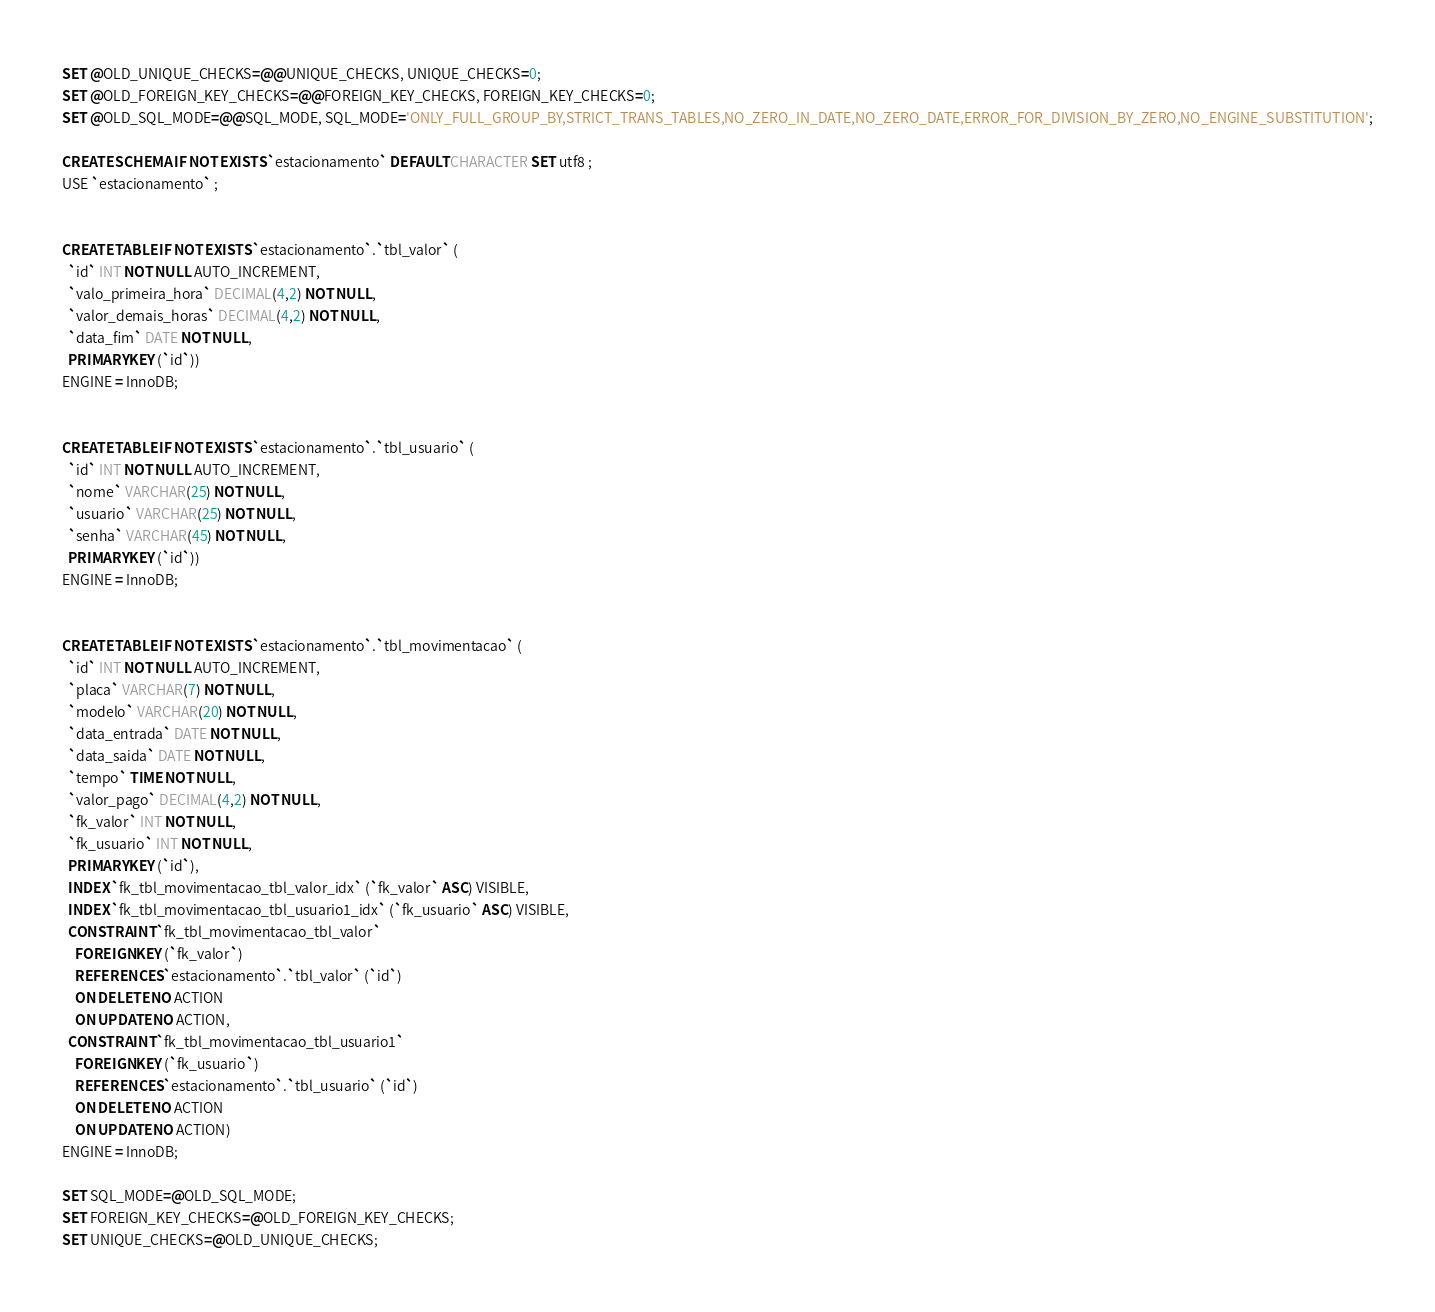<code> <loc_0><loc_0><loc_500><loc_500><_SQL_>
SET @OLD_UNIQUE_CHECKS=@@UNIQUE_CHECKS, UNIQUE_CHECKS=0;
SET @OLD_FOREIGN_KEY_CHECKS=@@FOREIGN_KEY_CHECKS, FOREIGN_KEY_CHECKS=0;
SET @OLD_SQL_MODE=@@SQL_MODE, SQL_MODE='ONLY_FULL_GROUP_BY,STRICT_TRANS_TABLES,NO_ZERO_IN_DATE,NO_ZERO_DATE,ERROR_FOR_DIVISION_BY_ZERO,NO_ENGINE_SUBSTITUTION';

CREATE SCHEMA IF NOT EXISTS `estacionamento` DEFAULT CHARACTER SET utf8 ;
USE `estacionamento` ;


CREATE TABLE IF NOT EXISTS `estacionamento`.`tbl_valor` (
  `id` INT NOT NULL AUTO_INCREMENT,
  `valo_primeira_hora` DECIMAL(4,2) NOT NULL,
  `valor_demais_horas` DECIMAL(4,2) NOT NULL,
  `data_fim` DATE NOT NULL,
  PRIMARY KEY (`id`))
ENGINE = InnoDB;


CREATE TABLE IF NOT EXISTS `estacionamento`.`tbl_usuario` (
  `id` INT NOT NULL AUTO_INCREMENT,
  `nome` VARCHAR(25) NOT NULL,
  `usuario` VARCHAR(25) NOT NULL,
  `senha` VARCHAR(45) NOT NULL,
  PRIMARY KEY (`id`))
ENGINE = InnoDB;


CREATE TABLE IF NOT EXISTS `estacionamento`.`tbl_movimentacao` (
  `id` INT NOT NULL AUTO_INCREMENT,
  `placa` VARCHAR(7) NOT NULL,
  `modelo` VARCHAR(20) NOT NULL,
  `data_entrada` DATE NOT NULL,
  `data_saida` DATE NOT NULL,
  `tempo` TIME NOT NULL,
  `valor_pago` DECIMAL(4,2) NOT NULL,
  `fk_valor` INT NOT NULL,
  `fk_usuario` INT NOT NULL,
  PRIMARY KEY (`id`),
  INDEX `fk_tbl_movimentacao_tbl_valor_idx` (`fk_valor` ASC) VISIBLE,
  INDEX `fk_tbl_movimentacao_tbl_usuario1_idx` (`fk_usuario` ASC) VISIBLE,
  CONSTRAINT `fk_tbl_movimentacao_tbl_valor`
    FOREIGN KEY (`fk_valor`)
    REFERENCES `estacionamento`.`tbl_valor` (`id`)
    ON DELETE NO ACTION
    ON UPDATE NO ACTION,
  CONSTRAINT `fk_tbl_movimentacao_tbl_usuario1`
    FOREIGN KEY (`fk_usuario`)
    REFERENCES `estacionamento`.`tbl_usuario` (`id`)
    ON DELETE NO ACTION
    ON UPDATE NO ACTION)
ENGINE = InnoDB;

SET SQL_MODE=@OLD_SQL_MODE;
SET FOREIGN_KEY_CHECKS=@OLD_FOREIGN_KEY_CHECKS;
SET UNIQUE_CHECKS=@OLD_UNIQUE_CHECKS;
</code> 